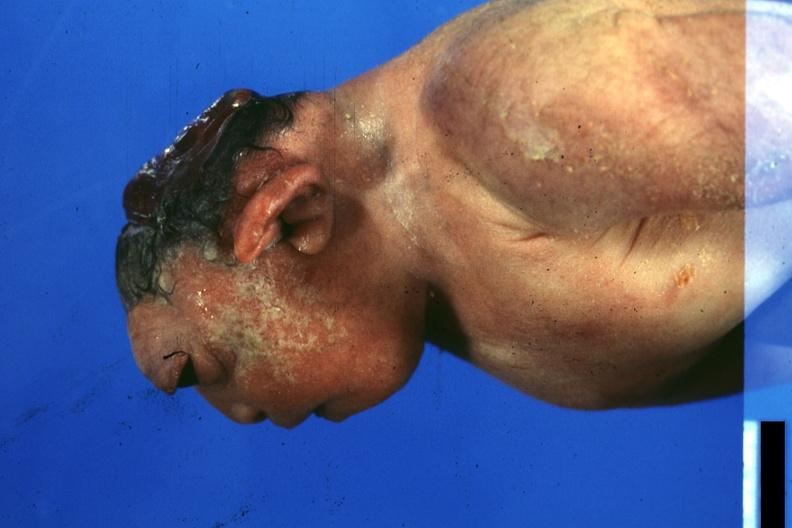does this image show lateral view of typical case?
Answer the question using a single word or phrase. Yes 